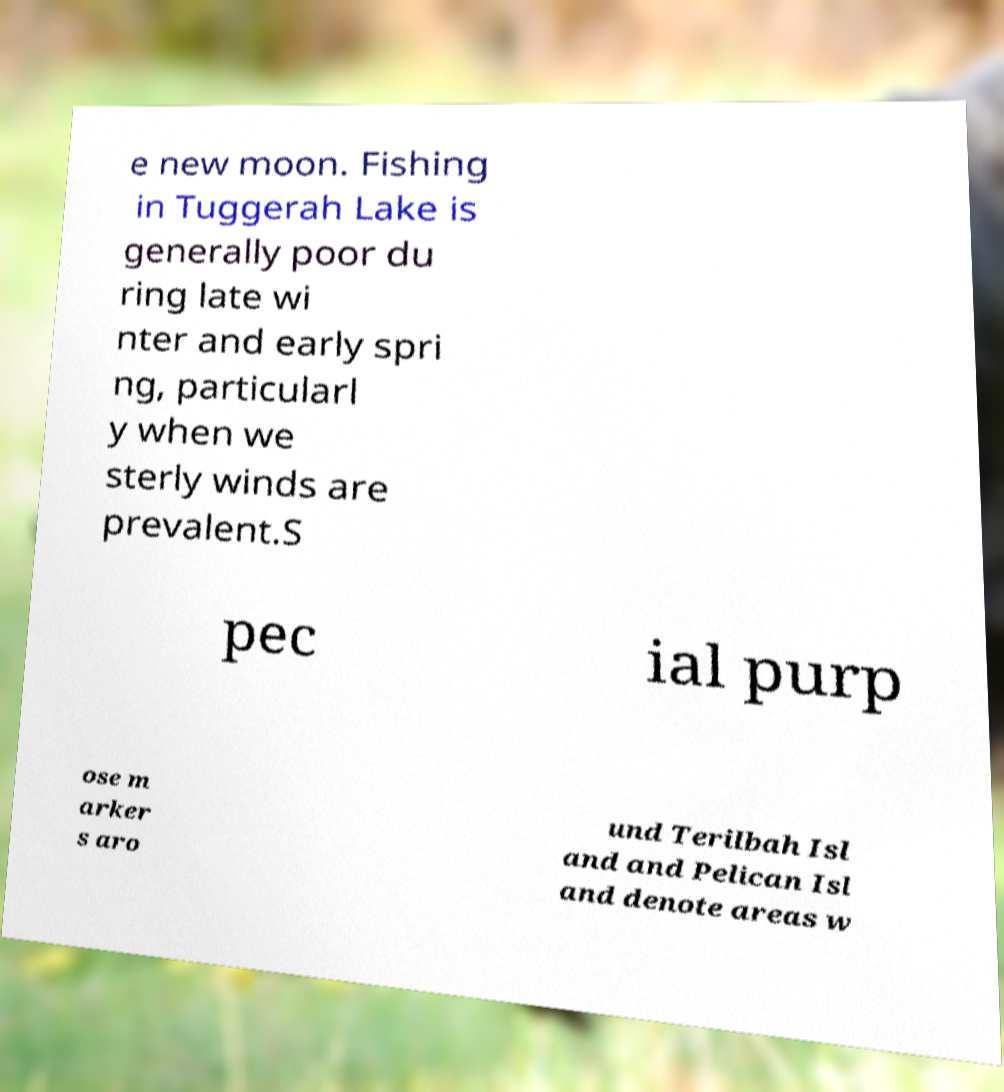Please identify and transcribe the text found in this image. e new moon. Fishing in Tuggerah Lake is generally poor du ring late wi nter and early spri ng, particularl y when we sterly winds are prevalent.S pec ial purp ose m arker s aro und Terilbah Isl and and Pelican Isl and denote areas w 